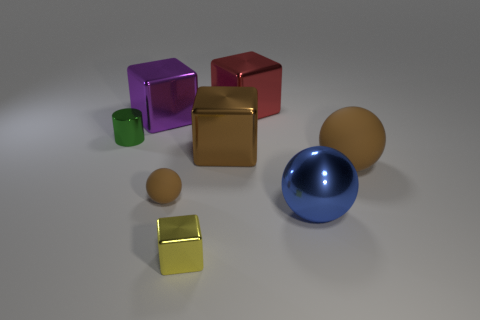Is the color of the small matte sphere the same as the big matte thing?
Provide a succinct answer. Yes. There is a small object that is right of the brown sphere that is to the left of the tiny yellow cube; what is its material?
Your response must be concise. Metal. The yellow shiny block has what size?
Offer a very short reply. Small. What size is the red thing that is made of the same material as the tiny cylinder?
Your answer should be very brief. Large. Is the size of the cylinder that is to the left of the brown cube the same as the small brown matte thing?
Provide a succinct answer. Yes. There is a small metallic object that is right of the brown ball that is to the left of the brown matte object that is behind the tiny brown ball; what is its shape?
Offer a very short reply. Cube. How many things are tiny green objects or things behind the blue metal ball?
Ensure brevity in your answer.  6. There is a brown object that is right of the brown cube; how big is it?
Provide a short and direct response. Large. What shape is the big shiny object that is the same color as the small rubber thing?
Provide a short and direct response. Cube. Are the blue thing and the brown thing that is to the left of the yellow metal block made of the same material?
Keep it short and to the point. No. 